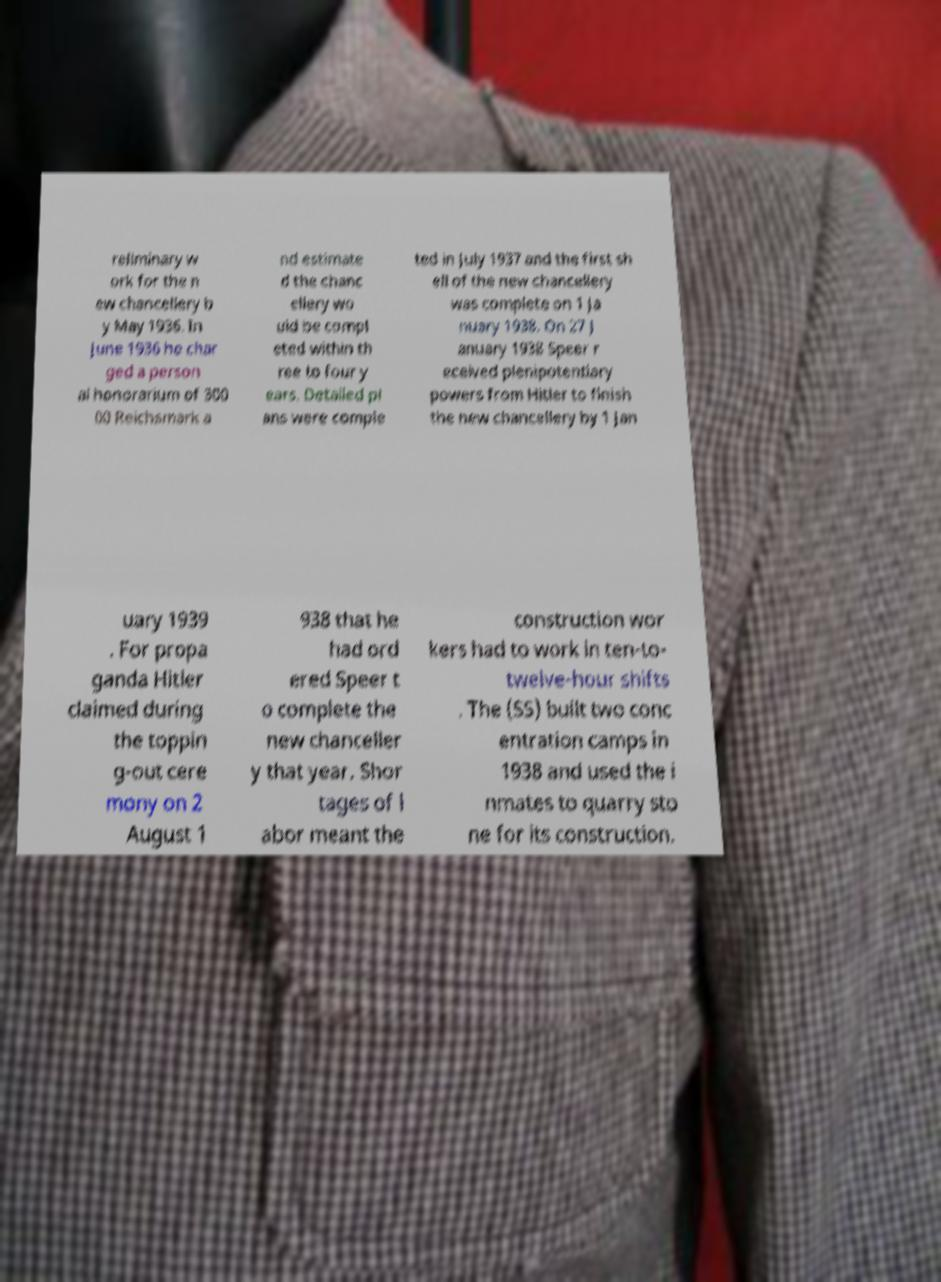There's text embedded in this image that I need extracted. Can you transcribe it verbatim? reliminary w ork for the n ew chancellery b y May 1936. In June 1936 he char ged a person al honorarium of 300 00 Reichsmark a nd estimate d the chanc ellery wo uld be compl eted within th ree to four y ears. Detailed pl ans were comple ted in July 1937 and the first sh ell of the new chancellery was complete on 1 Ja nuary 1938. On 27 J anuary 1938 Speer r eceived plenipotentiary powers from Hitler to finish the new chancellery by 1 Jan uary 1939 . For propa ganda Hitler claimed during the toppin g-out cere mony on 2 August 1 938 that he had ord ered Speer t o complete the new chanceller y that year. Shor tages of l abor meant the construction wor kers had to work in ten-to- twelve-hour shifts . The (SS) built two conc entration camps in 1938 and used the i nmates to quarry sto ne for its construction. 